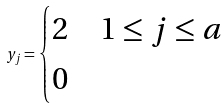<formula> <loc_0><loc_0><loc_500><loc_500>y _ { j } = \begin{cases} 2 & 1 \leq j \leq a \\ 0 & \end{cases}</formula> 